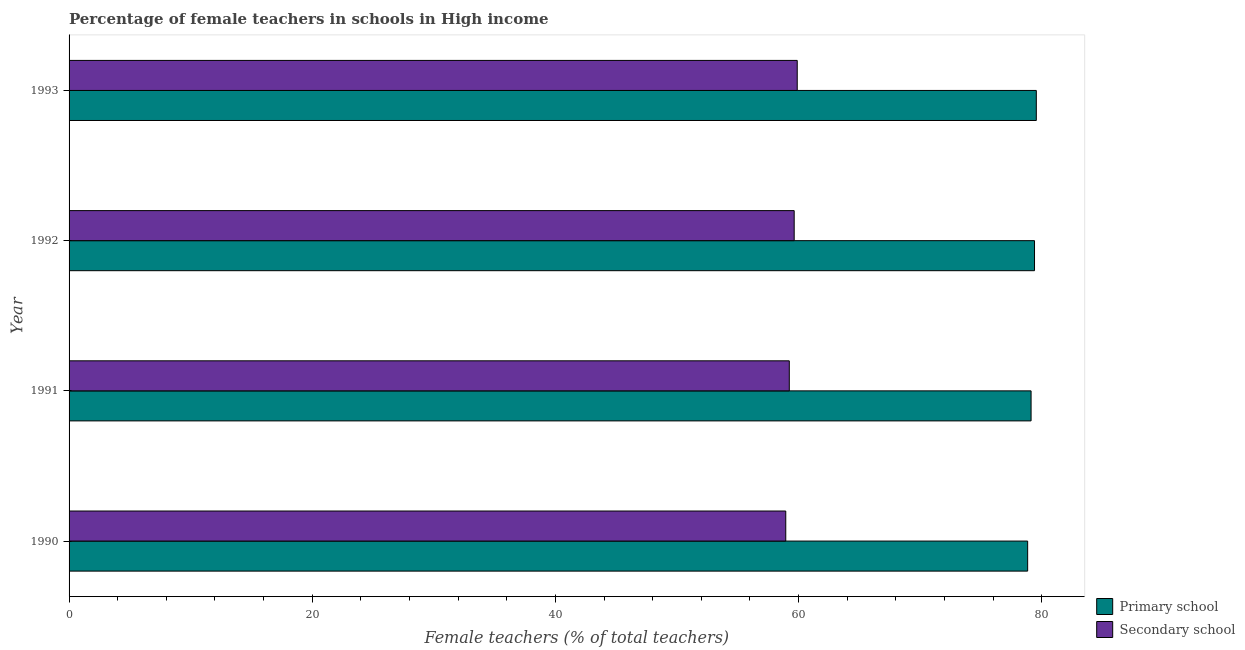Are the number of bars per tick equal to the number of legend labels?
Offer a terse response. Yes. Are the number of bars on each tick of the Y-axis equal?
Your answer should be compact. Yes. How many bars are there on the 4th tick from the top?
Your answer should be very brief. 2. In how many cases, is the number of bars for a given year not equal to the number of legend labels?
Make the answer very short. 0. What is the percentage of female teachers in secondary schools in 1992?
Your response must be concise. 59.64. Across all years, what is the maximum percentage of female teachers in secondary schools?
Ensure brevity in your answer.  59.89. Across all years, what is the minimum percentage of female teachers in primary schools?
Provide a short and direct response. 78.85. In which year was the percentage of female teachers in primary schools minimum?
Your response must be concise. 1990. What is the total percentage of female teachers in primary schools in the graph?
Provide a succinct answer. 316.94. What is the difference between the percentage of female teachers in primary schools in 1990 and that in 1991?
Keep it short and to the point. -0.28. What is the difference between the percentage of female teachers in secondary schools in 1991 and the percentage of female teachers in primary schools in 1992?
Keep it short and to the point. -20.17. What is the average percentage of female teachers in primary schools per year?
Provide a short and direct response. 79.23. In the year 1992, what is the difference between the percentage of female teachers in secondary schools and percentage of female teachers in primary schools?
Provide a short and direct response. -19.77. What is the ratio of the percentage of female teachers in secondary schools in 1990 to that in 1992?
Keep it short and to the point. 0.99. Is the percentage of female teachers in primary schools in 1990 less than that in 1992?
Provide a short and direct response. Yes. Is the difference between the percentage of female teachers in primary schools in 1992 and 1993 greater than the difference between the percentage of female teachers in secondary schools in 1992 and 1993?
Keep it short and to the point. Yes. In how many years, is the percentage of female teachers in secondary schools greater than the average percentage of female teachers in secondary schools taken over all years?
Provide a short and direct response. 2. What does the 1st bar from the top in 1993 represents?
Make the answer very short. Secondary school. What does the 1st bar from the bottom in 1992 represents?
Your answer should be compact. Primary school. How many bars are there?
Offer a very short reply. 8. How many years are there in the graph?
Make the answer very short. 4. Are the values on the major ticks of X-axis written in scientific E-notation?
Provide a succinct answer. No. Does the graph contain any zero values?
Make the answer very short. No. Does the graph contain grids?
Your answer should be very brief. No. Where does the legend appear in the graph?
Make the answer very short. Bottom right. How are the legend labels stacked?
Your answer should be very brief. Vertical. What is the title of the graph?
Your answer should be very brief. Percentage of female teachers in schools in High income. What is the label or title of the X-axis?
Provide a short and direct response. Female teachers (% of total teachers). What is the Female teachers (% of total teachers) in Primary school in 1990?
Offer a terse response. 78.85. What is the Female teachers (% of total teachers) in Secondary school in 1990?
Provide a short and direct response. 58.95. What is the Female teachers (% of total teachers) in Primary school in 1991?
Offer a very short reply. 79.13. What is the Female teachers (% of total teachers) in Secondary school in 1991?
Make the answer very short. 59.24. What is the Female teachers (% of total teachers) in Primary school in 1992?
Your answer should be very brief. 79.41. What is the Female teachers (% of total teachers) of Secondary school in 1992?
Keep it short and to the point. 59.64. What is the Female teachers (% of total teachers) in Primary school in 1993?
Provide a succinct answer. 79.56. What is the Female teachers (% of total teachers) in Secondary school in 1993?
Make the answer very short. 59.89. Across all years, what is the maximum Female teachers (% of total teachers) in Primary school?
Offer a terse response. 79.56. Across all years, what is the maximum Female teachers (% of total teachers) in Secondary school?
Provide a succinct answer. 59.89. Across all years, what is the minimum Female teachers (% of total teachers) of Primary school?
Provide a succinct answer. 78.85. Across all years, what is the minimum Female teachers (% of total teachers) of Secondary school?
Your response must be concise. 58.95. What is the total Female teachers (% of total teachers) of Primary school in the graph?
Your response must be concise. 316.94. What is the total Female teachers (% of total teachers) of Secondary school in the graph?
Offer a very short reply. 237.72. What is the difference between the Female teachers (% of total teachers) in Primary school in 1990 and that in 1991?
Your response must be concise. -0.28. What is the difference between the Female teachers (% of total teachers) in Secondary school in 1990 and that in 1991?
Your response must be concise. -0.29. What is the difference between the Female teachers (% of total teachers) in Primary school in 1990 and that in 1992?
Make the answer very short. -0.56. What is the difference between the Female teachers (% of total teachers) of Secondary school in 1990 and that in 1992?
Offer a terse response. -0.69. What is the difference between the Female teachers (% of total teachers) in Primary school in 1990 and that in 1993?
Provide a succinct answer. -0.71. What is the difference between the Female teachers (% of total teachers) in Secondary school in 1990 and that in 1993?
Give a very brief answer. -0.94. What is the difference between the Female teachers (% of total teachers) in Primary school in 1991 and that in 1992?
Offer a very short reply. -0.28. What is the difference between the Female teachers (% of total teachers) of Secondary school in 1991 and that in 1992?
Ensure brevity in your answer.  -0.4. What is the difference between the Female teachers (% of total teachers) of Primary school in 1991 and that in 1993?
Your response must be concise. -0.43. What is the difference between the Female teachers (% of total teachers) of Secondary school in 1991 and that in 1993?
Ensure brevity in your answer.  -0.65. What is the difference between the Female teachers (% of total teachers) of Primary school in 1992 and that in 1993?
Offer a terse response. -0.15. What is the difference between the Female teachers (% of total teachers) in Secondary school in 1992 and that in 1993?
Make the answer very short. -0.25. What is the difference between the Female teachers (% of total teachers) in Primary school in 1990 and the Female teachers (% of total teachers) in Secondary school in 1991?
Give a very brief answer. 19.61. What is the difference between the Female teachers (% of total teachers) in Primary school in 1990 and the Female teachers (% of total teachers) in Secondary school in 1992?
Your response must be concise. 19.2. What is the difference between the Female teachers (% of total teachers) of Primary school in 1990 and the Female teachers (% of total teachers) of Secondary school in 1993?
Provide a succinct answer. 18.95. What is the difference between the Female teachers (% of total teachers) of Primary school in 1991 and the Female teachers (% of total teachers) of Secondary school in 1992?
Keep it short and to the point. 19.49. What is the difference between the Female teachers (% of total teachers) of Primary school in 1991 and the Female teachers (% of total teachers) of Secondary school in 1993?
Your response must be concise. 19.23. What is the difference between the Female teachers (% of total teachers) in Primary school in 1992 and the Female teachers (% of total teachers) in Secondary school in 1993?
Ensure brevity in your answer.  19.52. What is the average Female teachers (% of total teachers) of Primary school per year?
Provide a short and direct response. 79.23. What is the average Female teachers (% of total teachers) in Secondary school per year?
Keep it short and to the point. 59.43. In the year 1990, what is the difference between the Female teachers (% of total teachers) in Primary school and Female teachers (% of total teachers) in Secondary school?
Your answer should be compact. 19.9. In the year 1991, what is the difference between the Female teachers (% of total teachers) in Primary school and Female teachers (% of total teachers) in Secondary school?
Offer a very short reply. 19.89. In the year 1992, what is the difference between the Female teachers (% of total teachers) in Primary school and Female teachers (% of total teachers) in Secondary school?
Ensure brevity in your answer.  19.77. In the year 1993, what is the difference between the Female teachers (% of total teachers) in Primary school and Female teachers (% of total teachers) in Secondary school?
Ensure brevity in your answer.  19.67. What is the ratio of the Female teachers (% of total teachers) of Primary school in 1990 to that in 1991?
Offer a very short reply. 1. What is the ratio of the Female teachers (% of total teachers) in Secondary school in 1990 to that in 1991?
Provide a short and direct response. 1. What is the ratio of the Female teachers (% of total teachers) in Secondary school in 1990 to that in 1992?
Offer a terse response. 0.99. What is the ratio of the Female teachers (% of total teachers) in Secondary school in 1990 to that in 1993?
Your response must be concise. 0.98. What is the ratio of the Female teachers (% of total teachers) of Primary school in 1991 to that in 1992?
Your response must be concise. 1. What is the ratio of the Female teachers (% of total teachers) in Secondary school in 1991 to that in 1992?
Ensure brevity in your answer.  0.99. What is the ratio of the Female teachers (% of total teachers) of Secondary school in 1991 to that in 1993?
Provide a short and direct response. 0.99. What is the ratio of the Female teachers (% of total teachers) in Primary school in 1992 to that in 1993?
Provide a succinct answer. 1. What is the difference between the highest and the second highest Female teachers (% of total teachers) in Primary school?
Your response must be concise. 0.15. What is the difference between the highest and the second highest Female teachers (% of total teachers) in Secondary school?
Your response must be concise. 0.25. What is the difference between the highest and the lowest Female teachers (% of total teachers) of Primary school?
Offer a terse response. 0.71. What is the difference between the highest and the lowest Female teachers (% of total teachers) of Secondary school?
Your answer should be very brief. 0.94. 